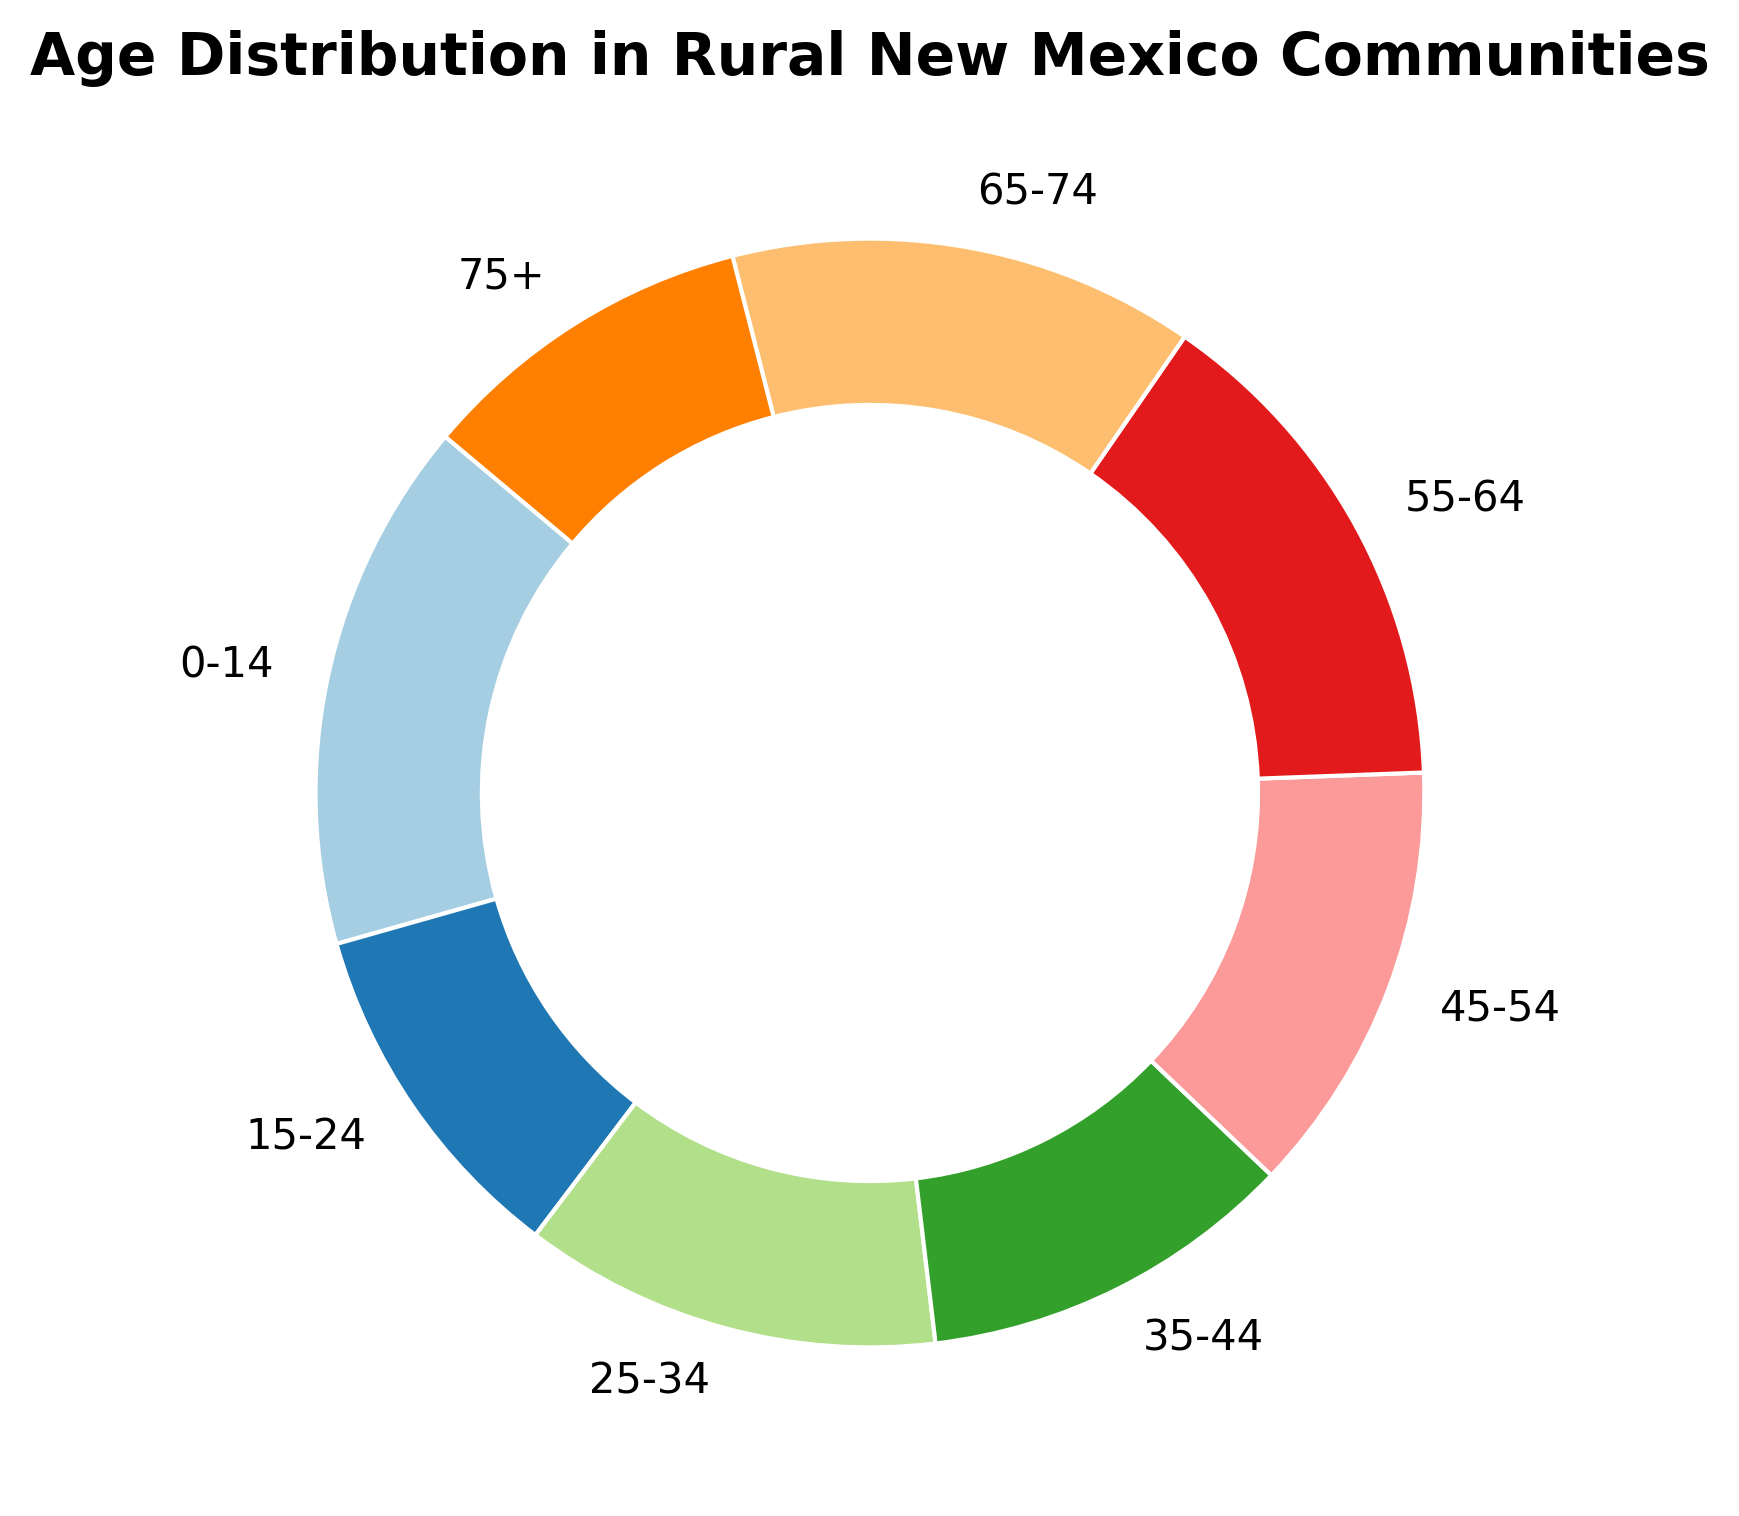What age group has the highest percentage of residents? To find the age group with the highest percentage of residents, look for the segment of the pie chart with the largest area. By inspecting the chart, you can identify that the age group with the highest percentage is 0-14 years.
Answer: 0-14 years Which age group has the lowest percentage representation? To determine the age group with the lowest percentage, find the smallest segment of the pie chart. The smallest segment is the 75+ age group.
Answer: 75+ years Is the percentage of residents aged 55-64 greater than the percentage of residents aged 25-34? Compare the segments for the two age groups. The segment for ages 55-64 is larger than the segment for ages 25-34. Therefore, 55-64 has a higher percentage.
Answer: Yes What is the total percentage of residents aged 0-14 and 15-24 combined? Add the percentages of both age groups: 15.5% (0-14) + 10.3% (15-24) = 25.8%.
Answer: 25.8% Which age group falls between 35-44 and 55-64 in terms of their percentage of residents? The age groups can be listed in descending order of percentage and checked for those between 35-44 and 55-64. They are 25-34 and 45-54.
Answer: 45-54 How much larger is the percentage of residents aged 55-64 compared to those aged 75+? Subtract the percentage for 75+ from the percentage for 55-64: 14.8% - 9.9% = 4.9%.
Answer: 4.9% Which age group has the closest percentage to 13.6%? Identify the percentage closest to 13.6%. The age group 45-54 has a percentage of 12.7%, which is closest to 13.6%.
Answer: 45-54 What is the sum of the percentages for residents aged 35-44, 45-54, and 65-74? Add the percentages for the three age groups: 11.0% (35-44) + 12.7% (45-54) + 13.6% (65-74) = 37.3%.
Answer: 37.3% How does the percentage of residents aged 15-24 compare visually to the percentage of residents aged 65-74? Visually inspect the pie chart segments for the two age groups. The 15-24 segment is visibly smaller than the 65-74 segment.
Answer: The 15-24 segment is smaller 